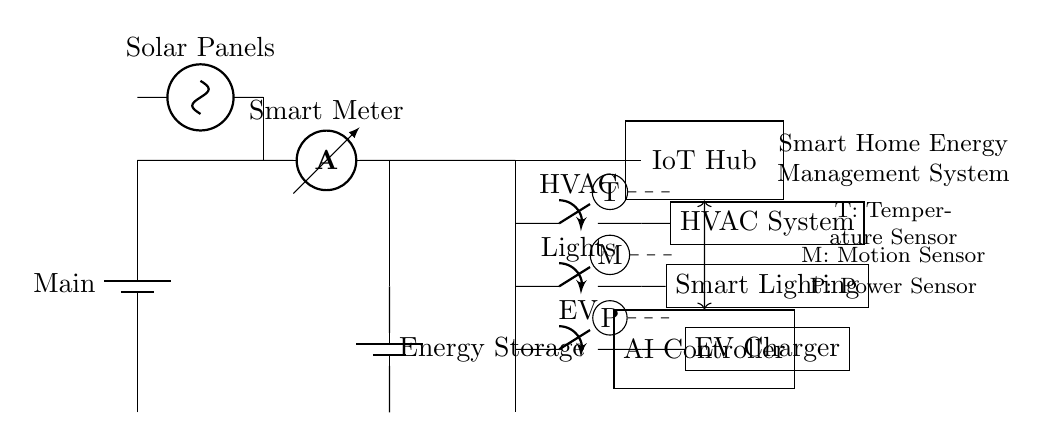What component is responsible for measuring current? The circuit diagram includes an ammeter, which is specifically designed to measure current in the circuit. It is located directly after the Smart Meter.
Answer: ammeter What type of system is represented in this circuit? The overall structure of the diagram is a Smart Home Energy Management System, indicated by the label at the right side of the circuit. This type of system optimizes energy usage in a household.
Answer: Smart Home Energy Management System How many appliances are directly controlled by the IoT Hub? The diagram shows three appliances (HVAC, Smart Lighting, and EV Charger) that are connected to the IoT Hub. Each appliance is connected via a switch coming from the same line.
Answer: three Which component is used to store excess energy? The circuit features a battery storage unit, indicated as "Energy Storage," which is responsible for storing excess energy generated by solar panels or consumed by appliances.
Answer: Energy Storage What sensors are included in the system? The diagram displays three types of sensors: a temperature sensor, a motion sensor, and a power sensor, each indicated by circles and labeled T, M, and P, respectively.
Answer: Temperature, Motion, Power Which components are directly connected to the solar panels? The solar panels are directly connected to the smart meter and the battery storage, as indicated by the lines that lead from the solar panels to these components.
Answer: smart meter, battery storage What is the voltage type provided by the main power supply? The main power supply is drawn as a battery, which typically provides direct current; the diagram does not specify an exact voltage but implies the type is direct current.
Answer: direct current 